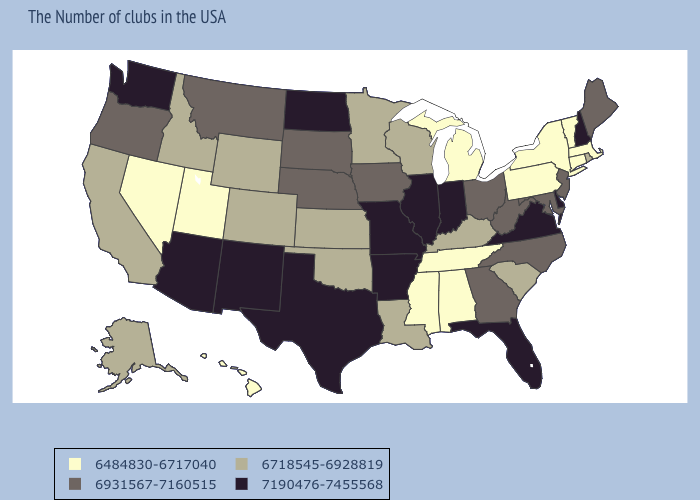Which states have the lowest value in the USA?
Short answer required. Massachusetts, Vermont, Connecticut, New York, Pennsylvania, Michigan, Alabama, Tennessee, Mississippi, Utah, Nevada, Hawaii. Does Illinois have the highest value in the MidWest?
Be succinct. Yes. Does the first symbol in the legend represent the smallest category?
Write a very short answer. Yes. What is the lowest value in states that border Louisiana?
Be succinct. 6484830-6717040. Name the states that have a value in the range 6718545-6928819?
Give a very brief answer. Rhode Island, South Carolina, Kentucky, Wisconsin, Louisiana, Minnesota, Kansas, Oklahoma, Wyoming, Colorado, Idaho, California, Alaska. Does Connecticut have the highest value in the USA?
Give a very brief answer. No. Name the states that have a value in the range 7190476-7455568?
Be succinct. New Hampshire, Delaware, Virginia, Florida, Indiana, Illinois, Missouri, Arkansas, Texas, North Dakota, New Mexico, Arizona, Washington. Does Alabama have the lowest value in the South?
Keep it brief. Yes. What is the value of New Hampshire?
Concise answer only. 7190476-7455568. Does Pennsylvania have the highest value in the USA?
Concise answer only. No. What is the highest value in states that border Oklahoma?
Be succinct. 7190476-7455568. Among the states that border Delaware , which have the highest value?
Answer briefly. New Jersey, Maryland. Does the first symbol in the legend represent the smallest category?
Answer briefly. Yes. What is the value of Oklahoma?
Concise answer only. 6718545-6928819. What is the lowest value in the West?
Be succinct. 6484830-6717040. 